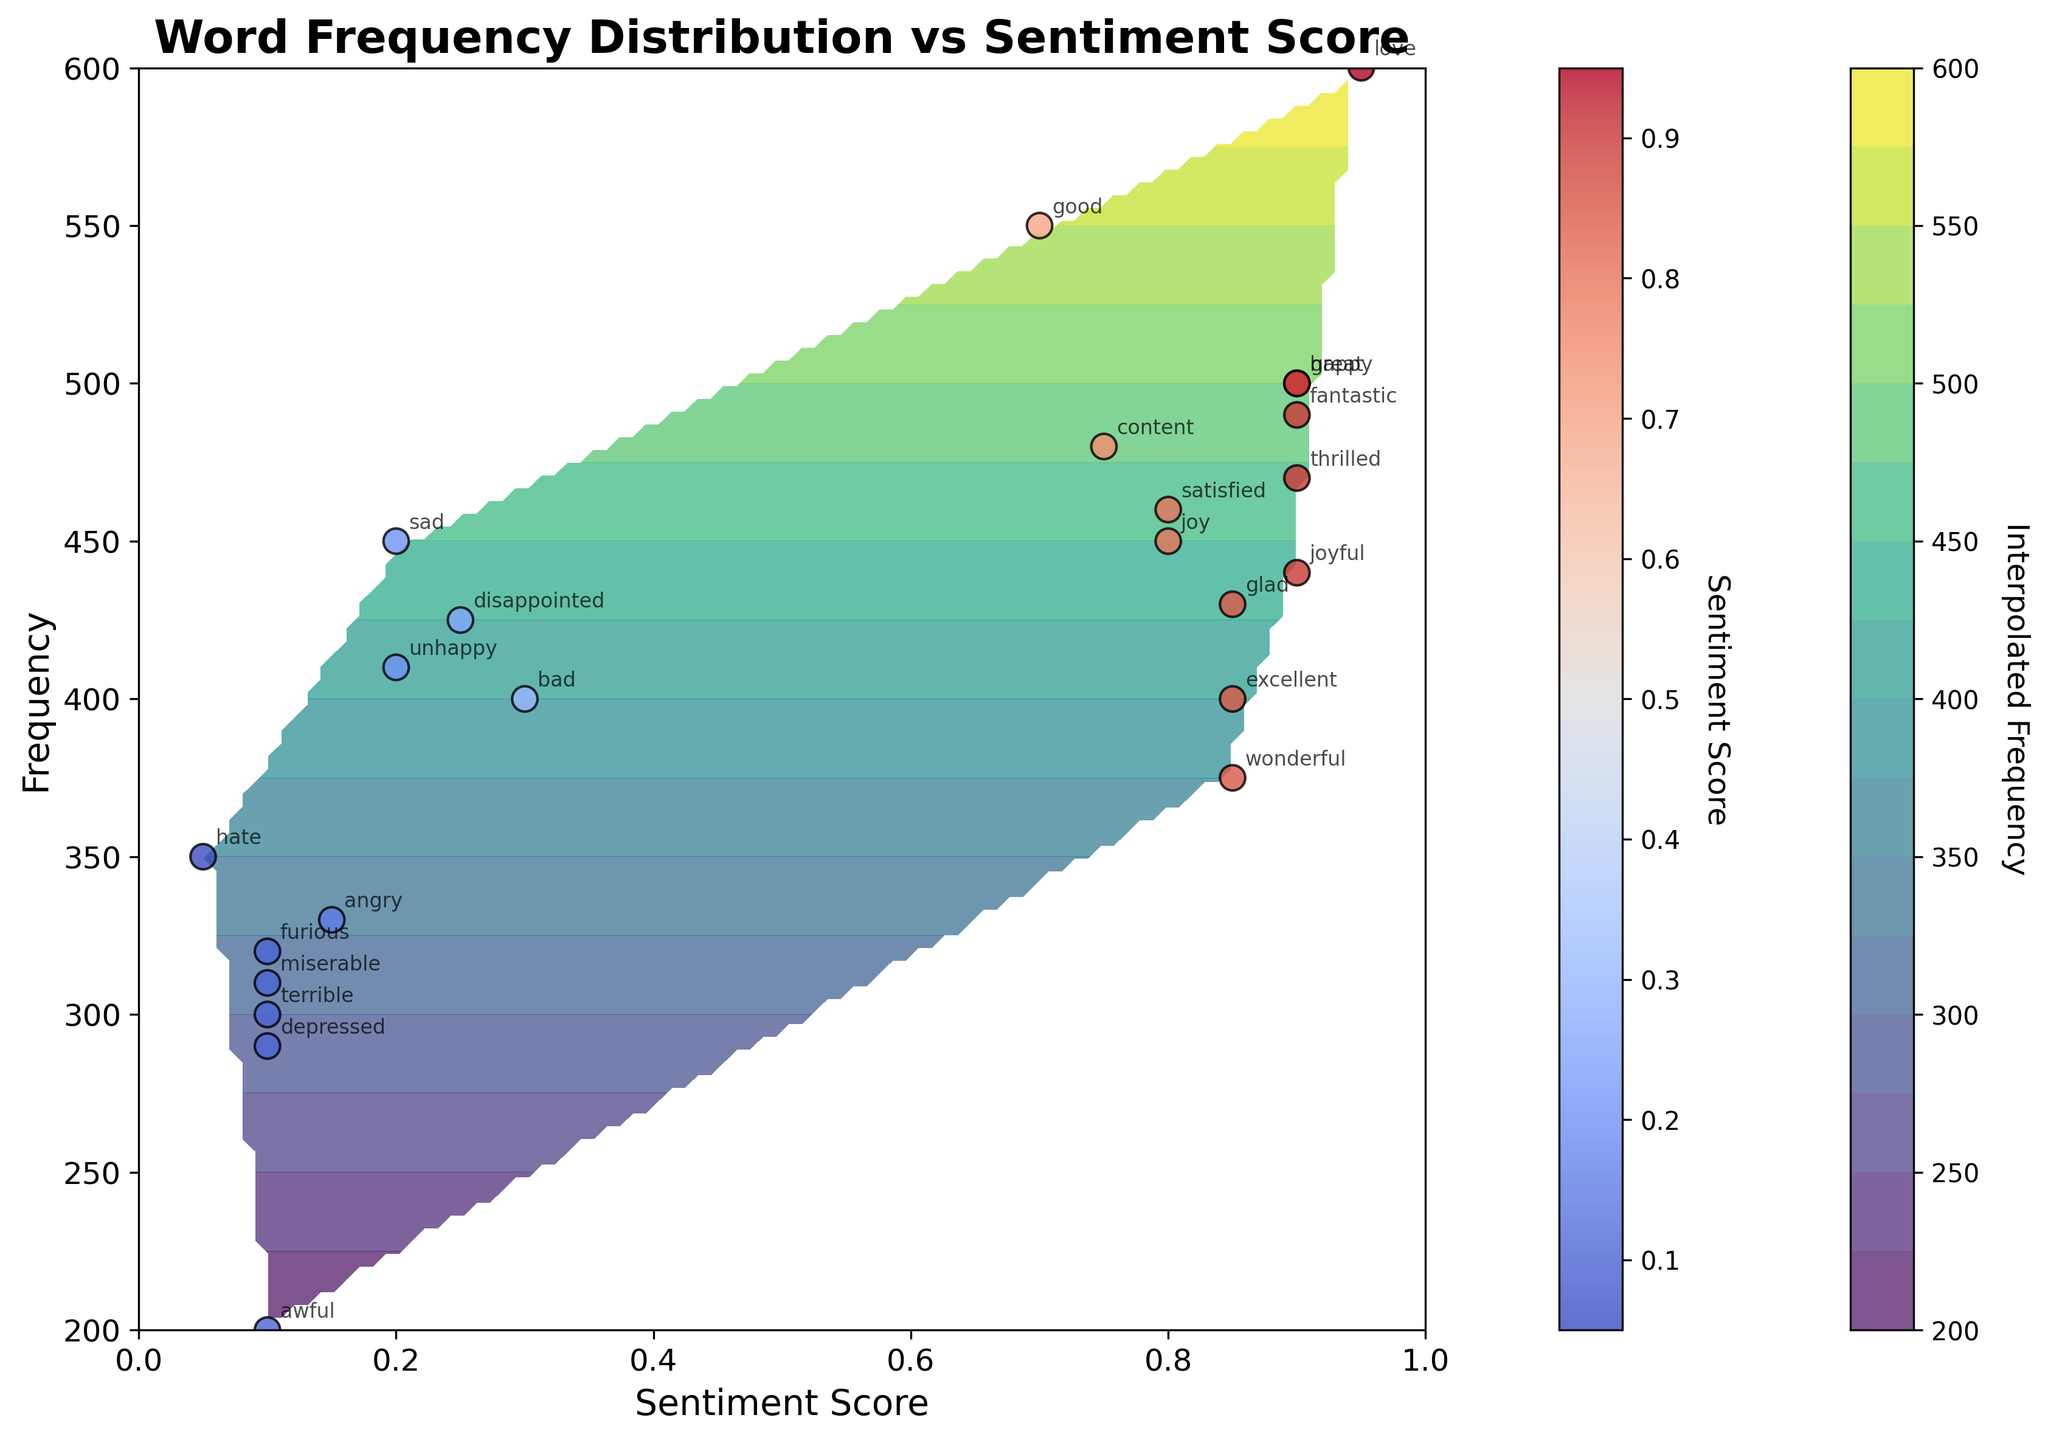How many levels of contour are depicted in the plot? The contour plot is divided into several levels, which define different ranges of interpolated frequencies. By counting the distinct contours in the color gradient, we observe there are 15 levels in total.
Answer: 15 What is the label of the color bar representing the interpolated data? The label of the color bar is shown next to the color gradient on the contour plot. It indicates the metric that the color scale represents, which in this case is "Interpolated Frequency."
Answer: Interpolated Frequency Which word has the highest frequency and what is its sentiment score? By examining the scatter points in the figure, we identify the word with the highest frequency based on its vertical position. The word "love" has the highest frequency of 600 and it has a sentiment score of 0.95 as shown by its location.
Answer: love, 0.95 What is the overall trend between sentiment score and frequency based on the scatter plot? Observing the scatter plot, a pattern emerges where higher sentiment scores generally correspond to higher frequencies. This suggests a positive correlation between sentiment score and word frequency.
Answer: Positive correlation Which word has a sentiment score closest to 0.8 and what is its frequency? By locating the scatter points near the sentiment score of 0.8 on the x-axis, we see that the word "joy" has a sentiment score of 0.8 with a frequency of 450.
Answer: joy, 450 How do the interpolated frequencies vary across different sentiment scores and ranges? Assessing the contour's color gradient, the interpolated frequencies show higher values around the middle to higher sentiment scores (e.g., 0.7 and above) and taper off at very low sentiment scores (e.g., below 0.2), reflecting the concentration of scatter points in these regions.
Answer: Interpolated frequencies are higher at middle to high sentiment scores Which words are placed at both extremes of the sentiment score spectrum in the scatter plot? Checking the edges of the sentiment score axis, "love" (0.95) and "fantastic" (0.9) are on the higher end, while "hate" (0.05), "terrible" (0.1), and "miserable" (0.1) are on the lower end.
Answer: love, fantastic, hate, terrible, miserable Which words are closest to the contour lines representing the highest interpolated frequencies? Examining the densest regions of the contour plot, where the highest interpolated frequencies are located, words like "good," "happy," and "thrilled" are near these lines.
Answer: good, happy, thrilled 